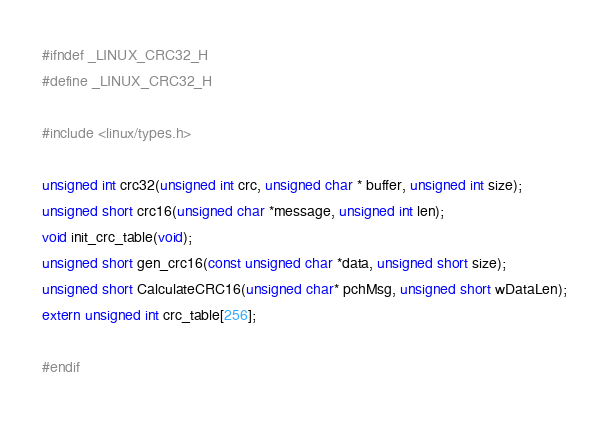Convert code to text. <code><loc_0><loc_0><loc_500><loc_500><_C_>#ifndef _LINUX_CRC32_H
#define _LINUX_CRC32_H

#include <linux/types.h>

unsigned int crc32(unsigned int crc, unsigned char * buffer, unsigned int size);
unsigned short crc16(unsigned char *message, unsigned int len);
void init_crc_table(void);
unsigned short gen_crc16(const unsigned char *data, unsigned short size);
unsigned short CalculateCRC16(unsigned char* pchMsg, unsigned short wDataLen);
extern unsigned int crc_table[256];

#endif 
</code> 